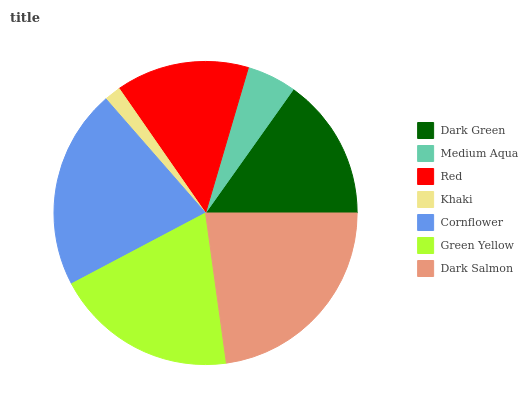Is Khaki the minimum?
Answer yes or no. Yes. Is Dark Salmon the maximum?
Answer yes or no. Yes. Is Medium Aqua the minimum?
Answer yes or no. No. Is Medium Aqua the maximum?
Answer yes or no. No. Is Dark Green greater than Medium Aqua?
Answer yes or no. Yes. Is Medium Aqua less than Dark Green?
Answer yes or no. Yes. Is Medium Aqua greater than Dark Green?
Answer yes or no. No. Is Dark Green less than Medium Aqua?
Answer yes or no. No. Is Dark Green the high median?
Answer yes or no. Yes. Is Dark Green the low median?
Answer yes or no. Yes. Is Green Yellow the high median?
Answer yes or no. No. Is Dark Salmon the low median?
Answer yes or no. No. 